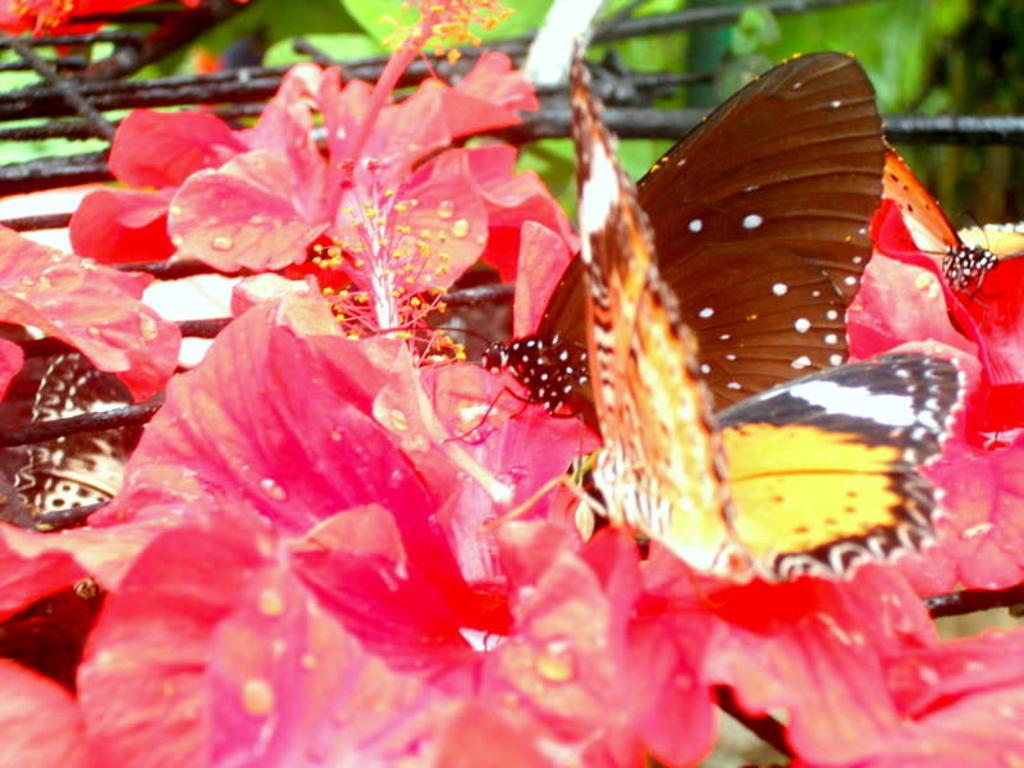What creatures can be seen in the image? There are butterflies in the image. Where are the butterflies located? The butterflies are on flowers. Can you describe the background of the image? The background of the image is blurred. What type of milk can be seen in the image? There is no milk present in the image; it features butterflies on flowers with a blurred background. 